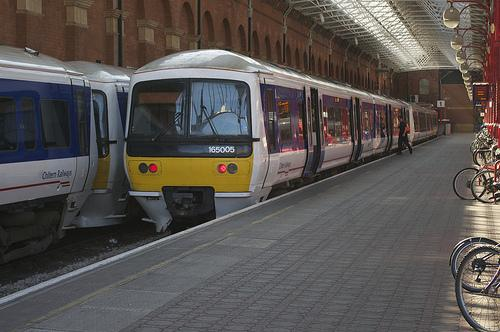Analyze the windows of the yellow and white train in terms of size and descriptions. The windows on the yellow and white train are rectangular and appear to be of standard size for commuter trains. They are evenly spaced along the side of the train. What action is the person in the image taking in relation to the train? The person is walking towards the train, possibly preparing to board it. Narrate the scene, detailing the state of the train and the objects surrounding it. The train is stationary at the platform, with its doors open, ready for passengers to board. Several bicycles are parked on the platform, and a person is walking towards the train. The platform is paved and appears clean. Mention the type of location where the train is, focusing on the platform and the structure. The train is at a station with a paved platform and a large, covered structure, possibly a terminal. The architecture includes red brick walls and arched openings. What are the different tasks that could be performed on the image based on the information provided? Tasks such as visual question answering (VQA), image segmentation, object detection, and scene recognition could be performed on this image. What is the position of the bikes in relation to the train and what is the state of the bikes? The bikes are parked on a rack to the right of the train, neatly aligned and appear to be secured. Identify the color of the paint on the train and the color of the light on the left side of the train. The train is primarily white with a yellow front, and the light on the left side of the train is white. Describe the appearance of the train, including its color and any visible numbers. The train is predominantly white with a yellow front section. It has visible numbers on the front, which read "165005". State the colors and positions of the two lights on the front of the train. There are two white lights on the front of the train, one on each side near the top of the yellow section. Can you find the green tree growing near the platform? There is no visible green tree near the platform in the image. Find the group of people waiting on the platform for the train. There is no group of people visible in the image; only one person is seen walking towards the train. Identify the parked car near the station entrance. There is no visible parked car near the station entrance in the image. Spot the snack vending machine at the train station. There is no snack vending machine visible in the image. Can you locate the purple train next to the white train? There is no purple train visible in the image; the adjacent train is blue and white. Locate the red rectangular luggage that a passenger has left behind. There is no visible red rectangular luggage or any luggage left behind in the image. 